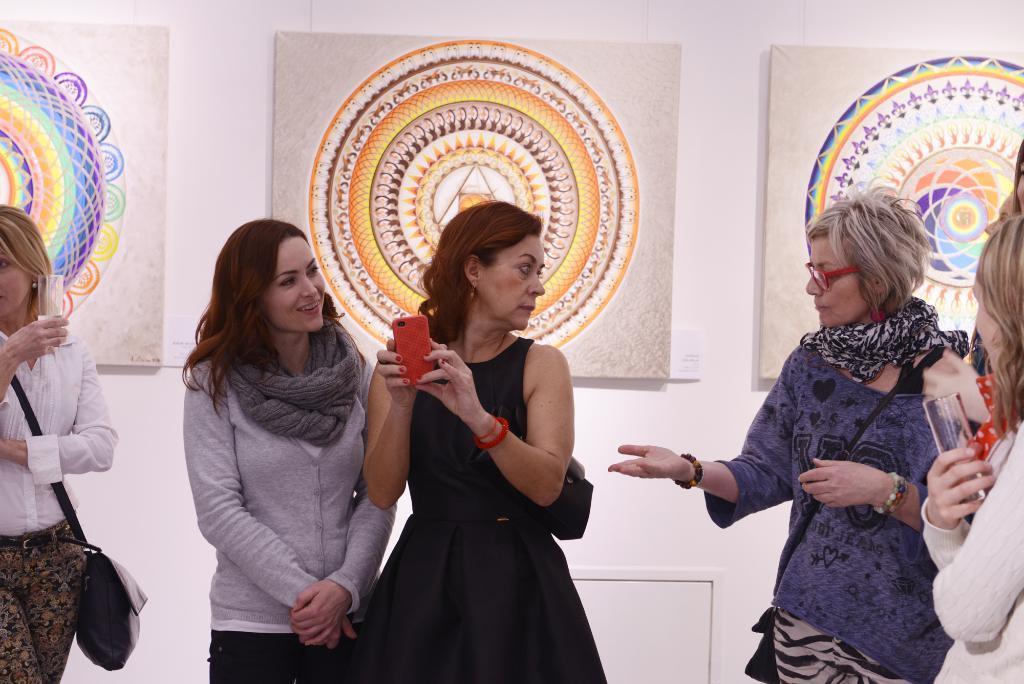In one or two sentences, can you explain what this image depicts? There are women in different color dresses, standing. One of them is smiling. In the background, there are paintings attached to the white wall. 